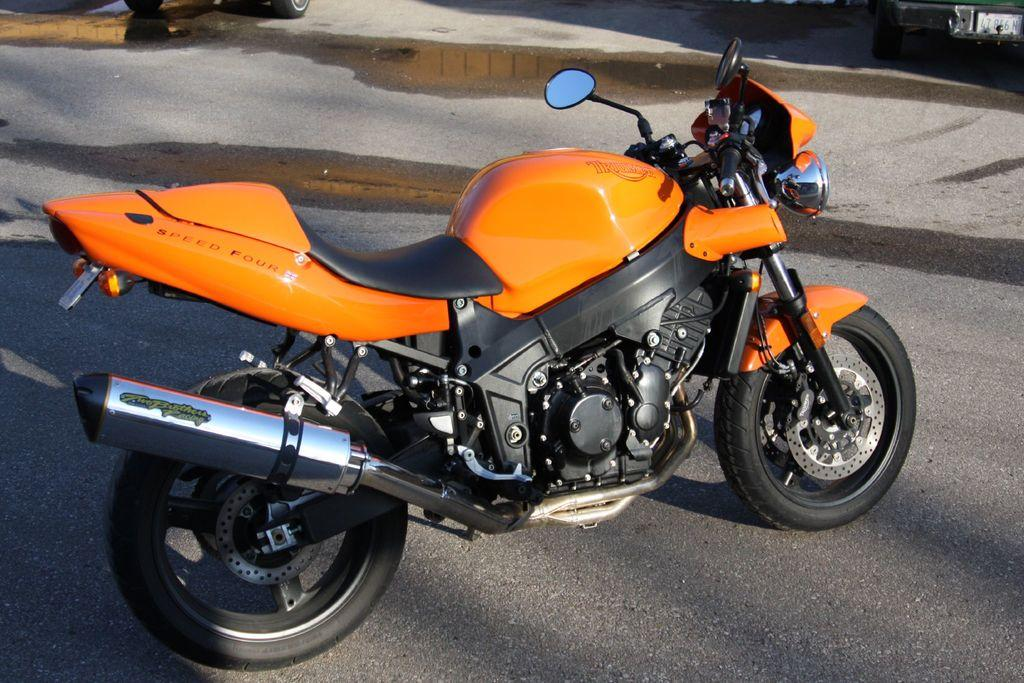What is the main subject of the image? The main subject of the image is a motorbike. What can be seen on the road in the image? There is water on the road in the image. What is visible at the top of the image? There are objects visible at the top of the image, but their specific nature is not mentioned in the facts. What type of force is being applied to the motorbike in the image? There is no information provided about any force being applied to the motorbike in the image. What line can be seen connecting the motorbike to the objects at the top of the image? There is no line connecting the motorbike to the objects at the top of the image, as the nature of these objects is not specified in the facts. 